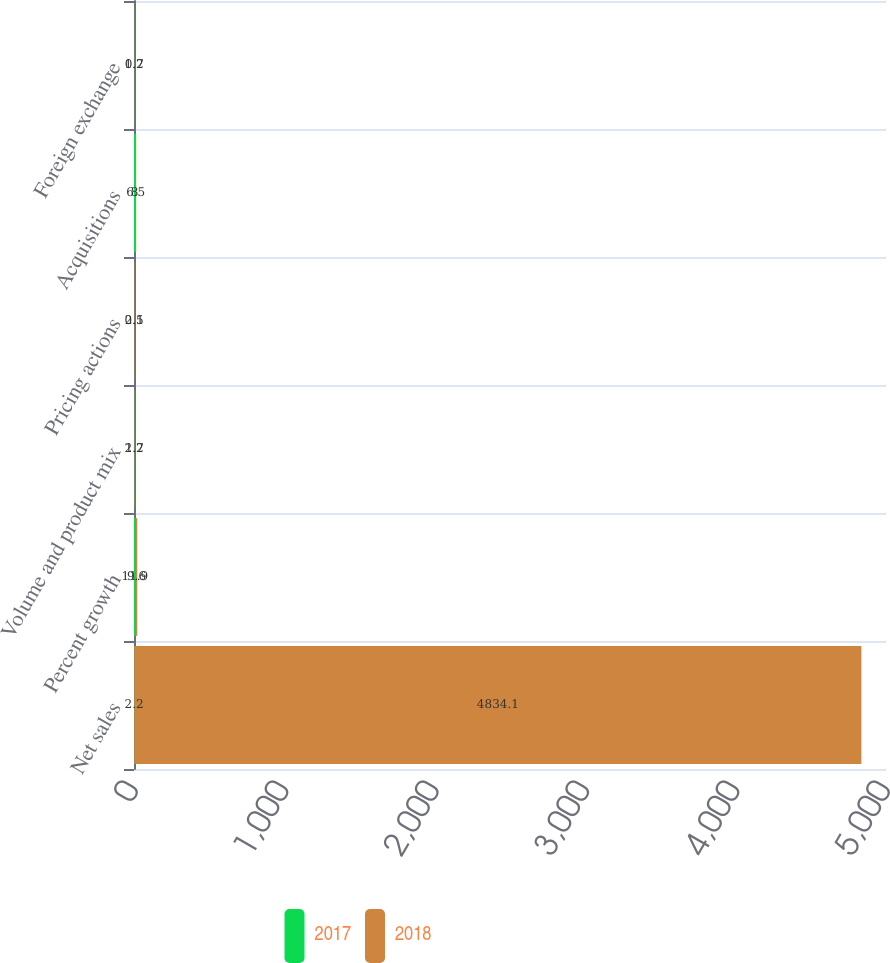<chart> <loc_0><loc_0><loc_500><loc_500><stacked_bar_chart><ecel><fcel>Net sales<fcel>Percent growth<fcel>Volume and product mix<fcel>Pricing actions<fcel>Acquisitions<fcel>Foreign exchange<nl><fcel>2017<fcel>2.2<fcel>11.9<fcel>2.2<fcel>0.5<fcel>8<fcel>1.2<nl><fcel>2018<fcel>4834.1<fcel>9.6<fcel>1.7<fcel>2.1<fcel>6.5<fcel>0.7<nl></chart> 